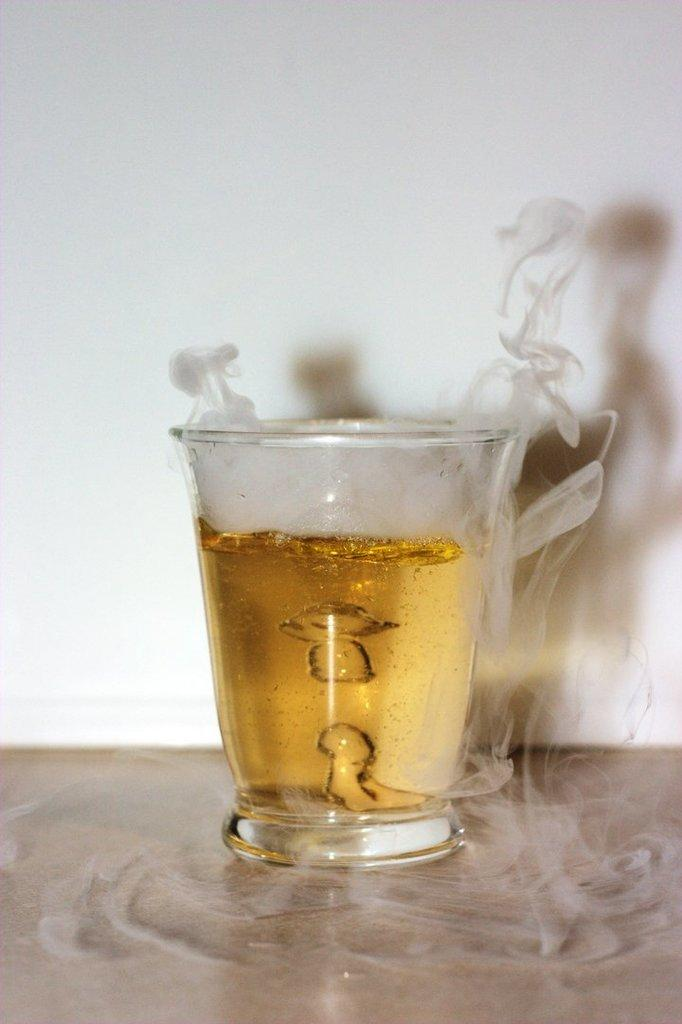What object is present in the image that can hold liquid? There is a cup in the image that can hold liquid. What is inside the cup? There is liquid in the cup. What is visible around the cup? There is steam around the cup. What can be seen in the background of the image? There is a wall in the background of the image. What is visible on the wall? The shadow of the cup and steam is visible on the wall. What type of rabbit can be seen holding a gun in the image? There is no rabbit or gun present in the image. 